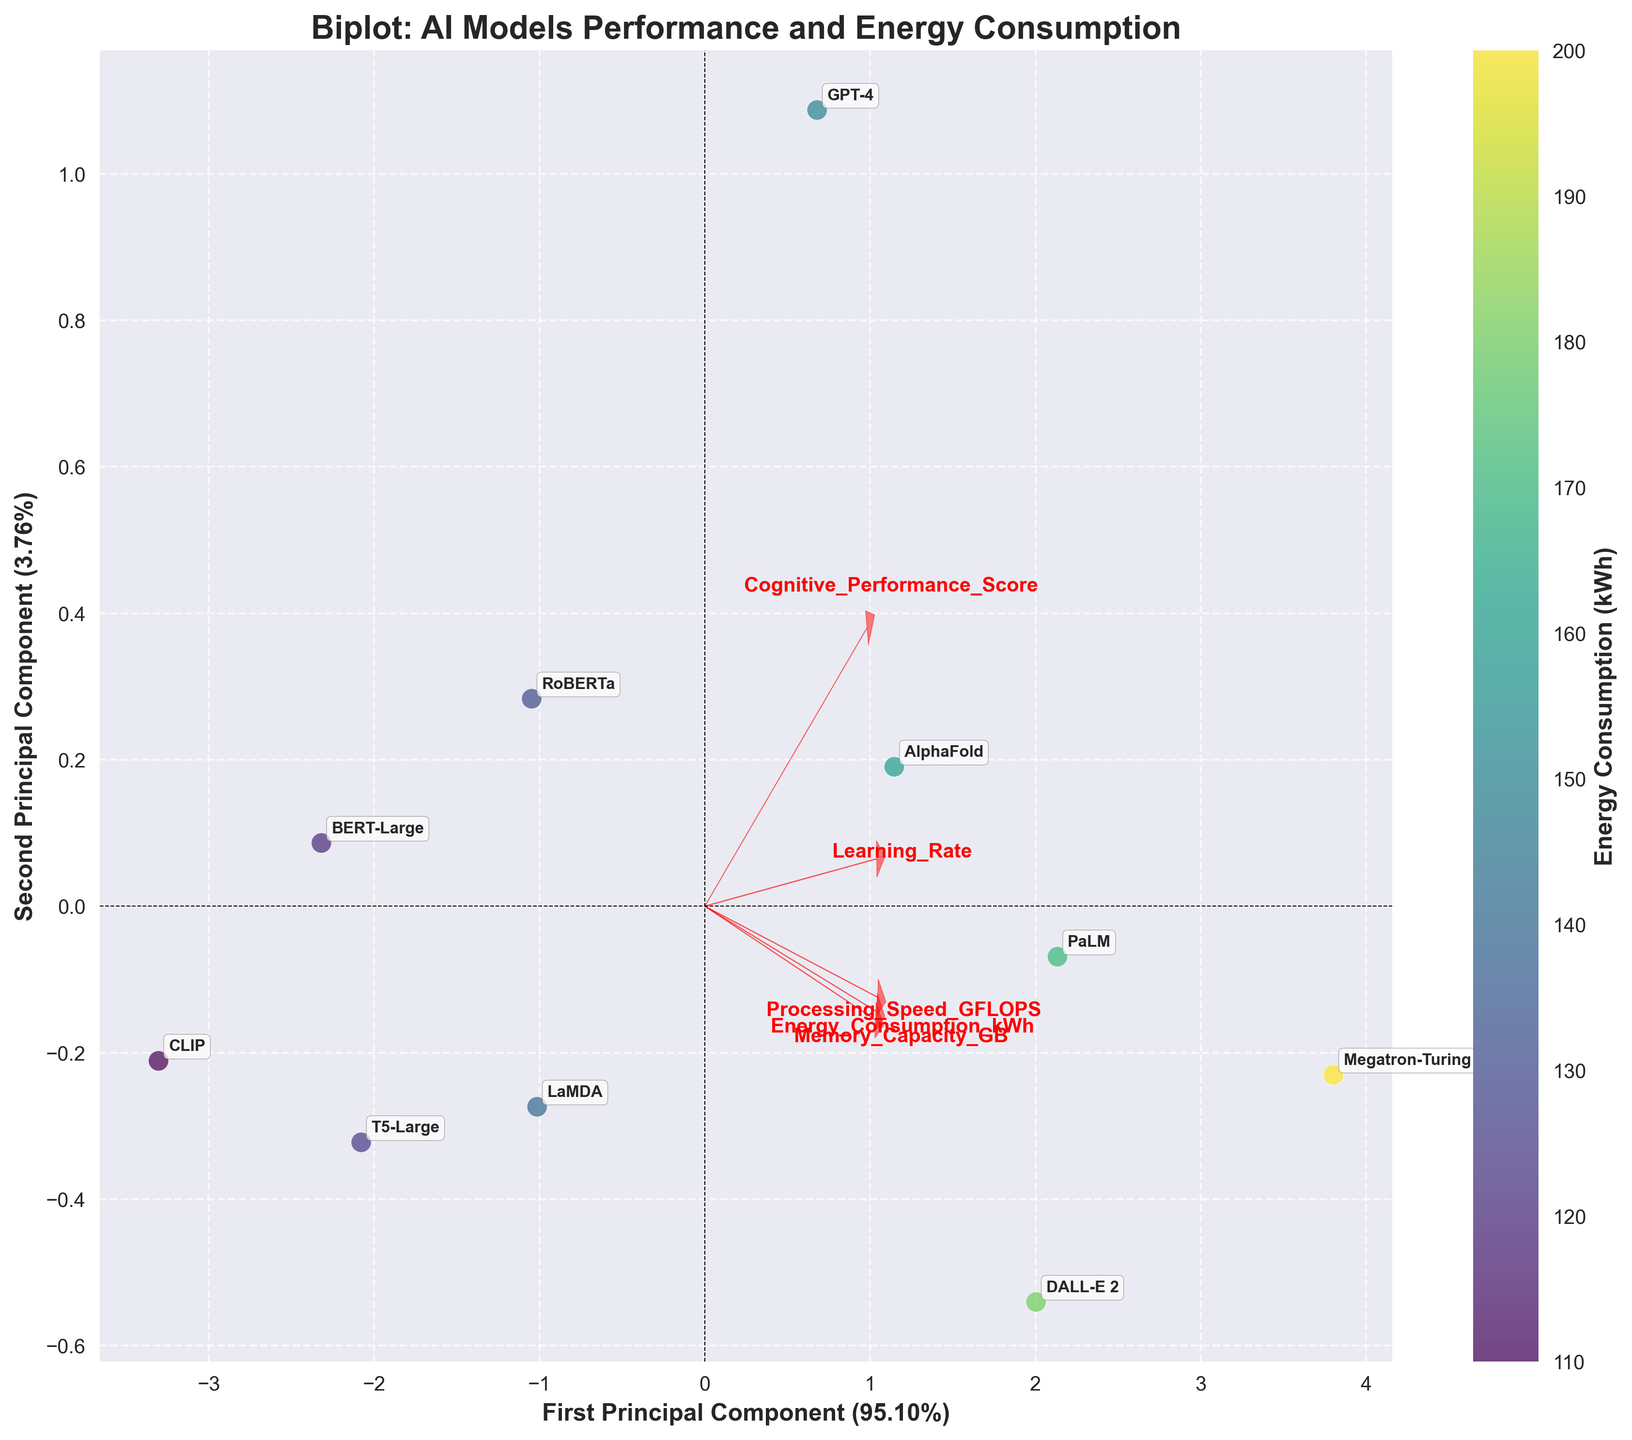What is the title of the plot? The title is usually placed at the top of the plot. Here, it prominently states the overall theme or subject of the visualization.
Answer: Biplot: AI Models Performance and Energy Consumption How many AI models are compared in the figure? By looking at the scatter plot, we count the number of unique annotations, each representing a different model.
Answer: 10 Which model has the highest energy consumption? Identify the data point with the highest value on the color bar or by referring to the annotations close to darker colors.
Answer: Megatron-Turing NLG Which AI models have arrows pointing directly towards them? Look at the arrows representing vectors in the plot; determine which models are aligned closely with these arrows.
Answer: GPT-4, BERT-Large, RoBERTa, DALL-E 2, AlphaFold, LaMDA, PaLM, CLIP, T5-Large, Megatron-Turing NLG What are the principal components labeled on the axes? Refer to the axis labels provided in the plot. The labels mention the names of the principal components along with their explained variance ratios.
Answer: First Principal Component and Second Principal Component How much variance is explained by the first principal component? Read the label of the x-axis where the explained variance percentage is mentioned for the first principal component.
Answer: 50% What factors strongly influence the first principal component? Look at the arrows’ directions and lengths; the longer arrows directed towards either principal component indicate strong influence.
Answer: Energy Consumption, Cognitive Performance, Memory Capacity, Processing Speed, Learning Rate Which AI model shows a balance in both principal components (near the origin)? Identify the data point closest to the origin (0,0) of the PCA plot.
Answer: BERT-Large Compare the cognitive performance scores of GPT-4 and DALL-E 2. Which is higher? Locate the respective annotations for GPT-4 and DALL-E 2 and compare their positions relative to the cognitive performance vector.
Answer: GPT-4 How does Processing Speed correlate with Energy Consumption based on the plot? Examine the orientation and length of the Processing Speed and Energy Consumption vectors to infer the relationship. Observing if these vectors point in a similar direction can indicate a positive correlation.
Answer: Positively correlated 